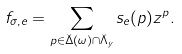<formula> <loc_0><loc_0><loc_500><loc_500>f _ { \sigma , e } = \sum _ { p \in \check { \Delta } ( \omega ) \cap \check { \Lambda } _ { y } } { s } _ { e } ( p ) z ^ { p } .</formula> 